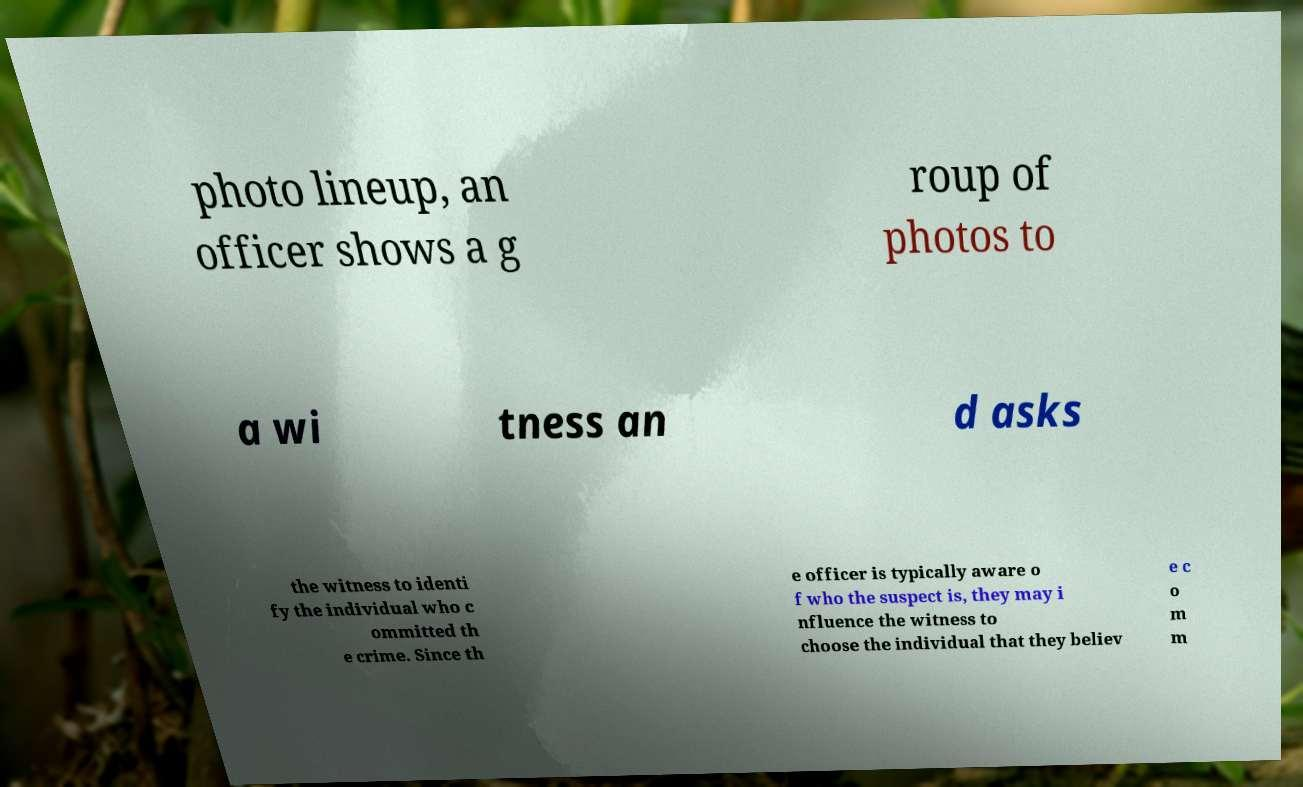Please identify and transcribe the text found in this image. photo lineup, an officer shows a g roup of photos to a wi tness an d asks the witness to identi fy the individual who c ommitted th e crime. Since th e officer is typically aware o f who the suspect is, they may i nfluence the witness to choose the individual that they believ e c o m m 